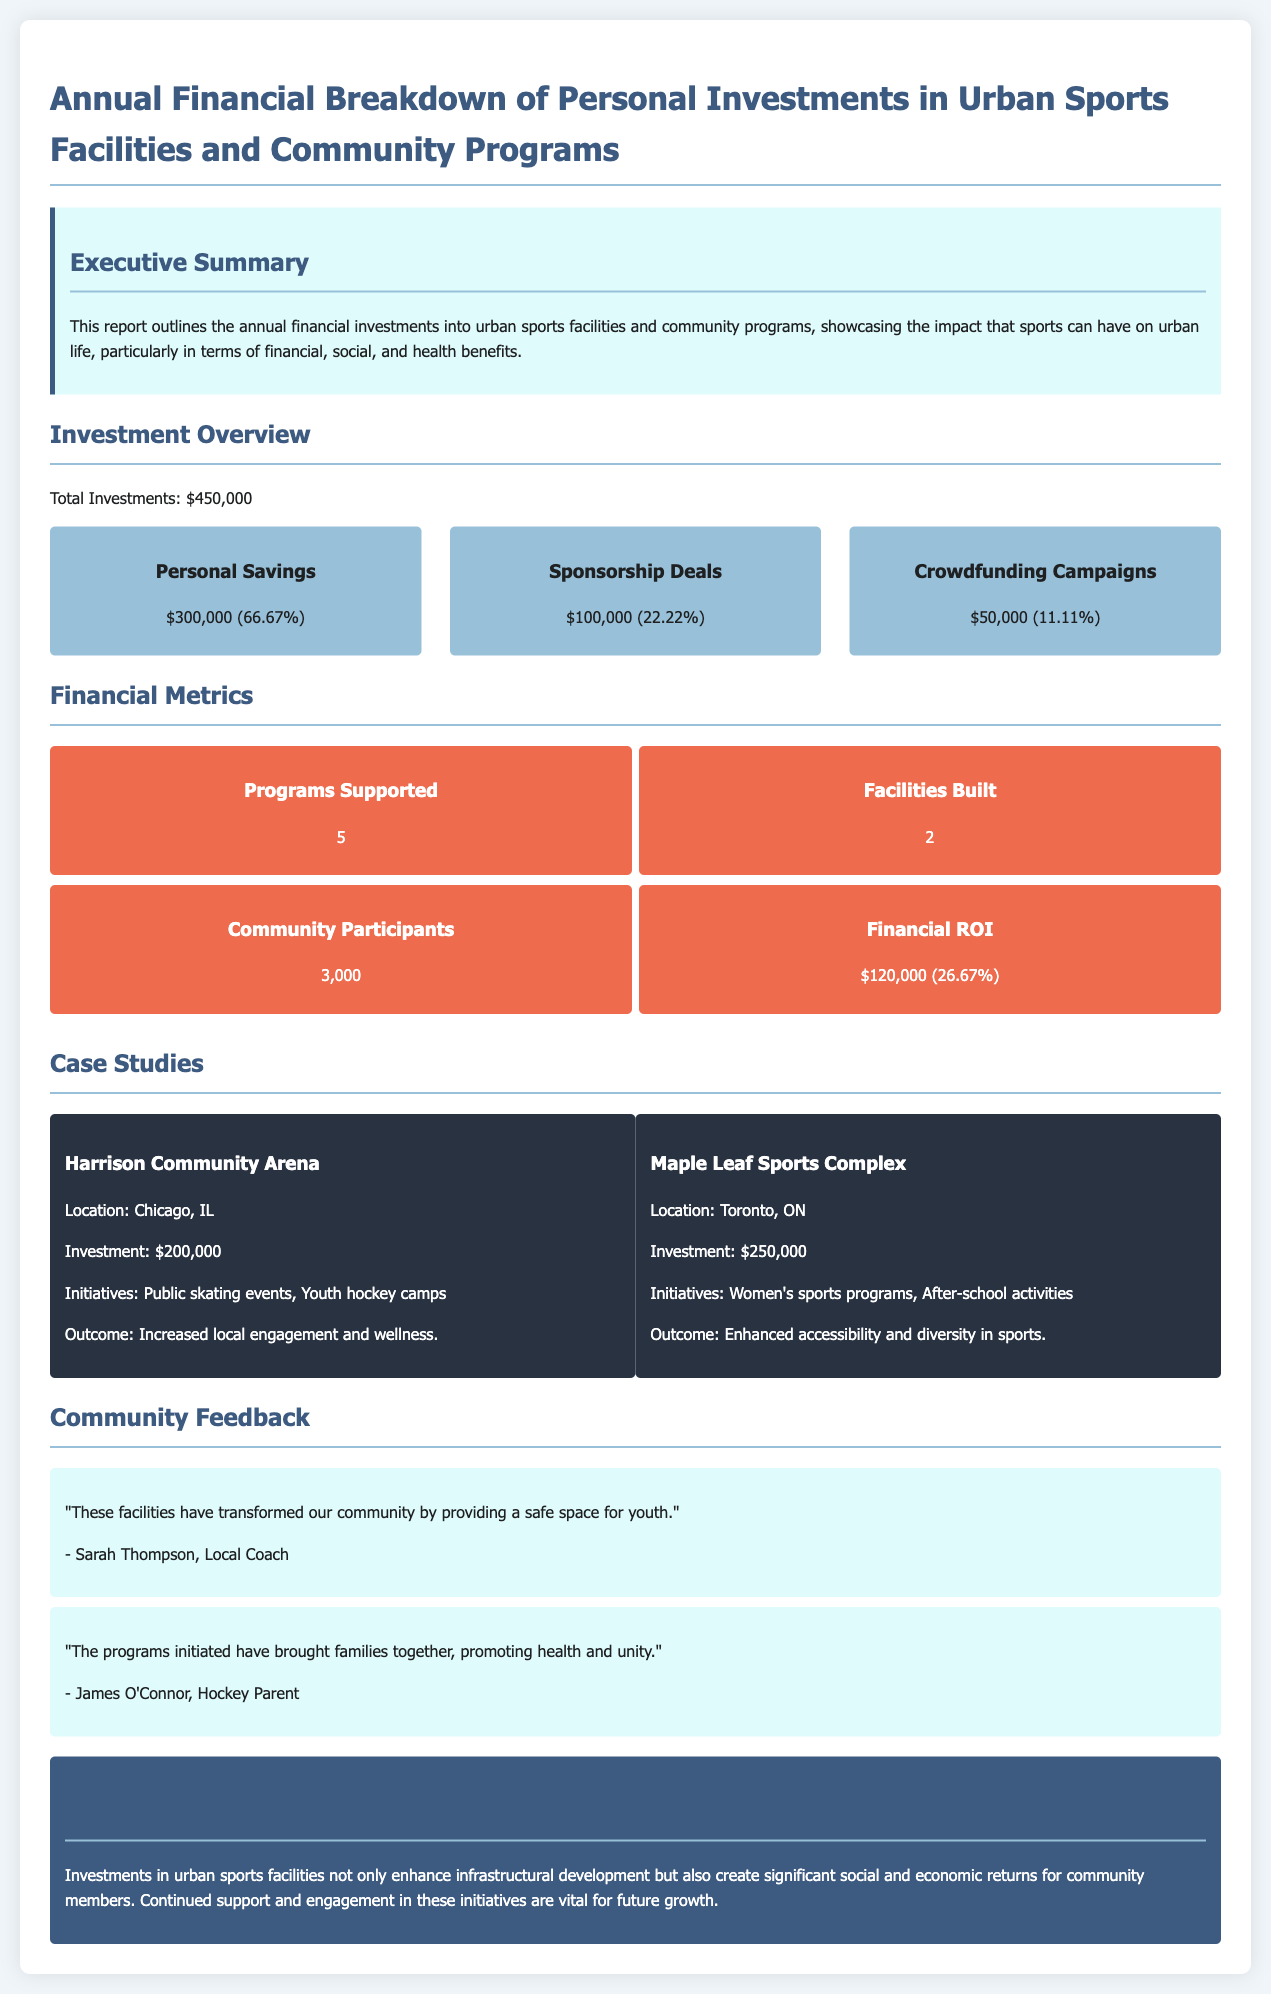what is the total investment amount? The total investment amount is explicitly stated in the report as $450,000.
Answer: $450,000 how much was invested from personal savings? The report indicates the amount invested from personal savings as $300,000, which is also noted as a percentage.
Answer: $300,000 what percentage of the investment comes from sponsorship deals? The investment from sponsorship deals is listed as $100,000, which corresponds to 22.22% of the total investment.
Answer: 22.22% how many community programs were supported? The report mentions that a total of 5 programs were supported through the investments made.
Answer: 5 which facility had an investment of $250,000? The Maple Leaf Sports Complex is explicitly mentioned as having received an investment of $250,000.
Answer: Maple Leaf Sports Complex what was the financial ROI percentage? The financial return on investment percentage given in the document is 26.67%.
Answer: 26.67% what city is the Harrison Community Arena located in? The location of the Harrison Community Arena is stated in the report as Chicago, IL.
Answer: Chicago, IL what is the outcome from the Maple Leaf Sports Complex initiatives? The outcome from the initiatives at the Maple Leaf Sports Complex is described as enhanced accessibility and diversity in sports.
Answer: Enhanced accessibility and diversity in sports who is referred to as a local coach in the community feedback section? Sarah Thompson is named as the local coach in the community feedback section.
Answer: Sarah Thompson 